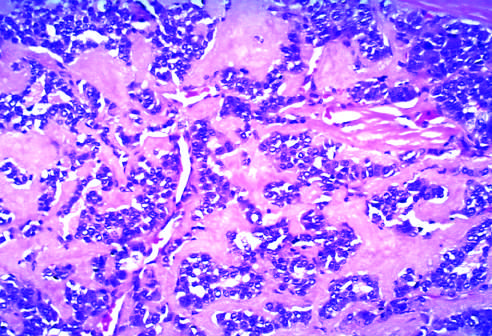do acute epididymitis contain amyloid, visible here as homogeneous extracellular material, derived from calcitonin molecules secreted by the neoplastic cells?
Answer the question using a single word or phrase. No 